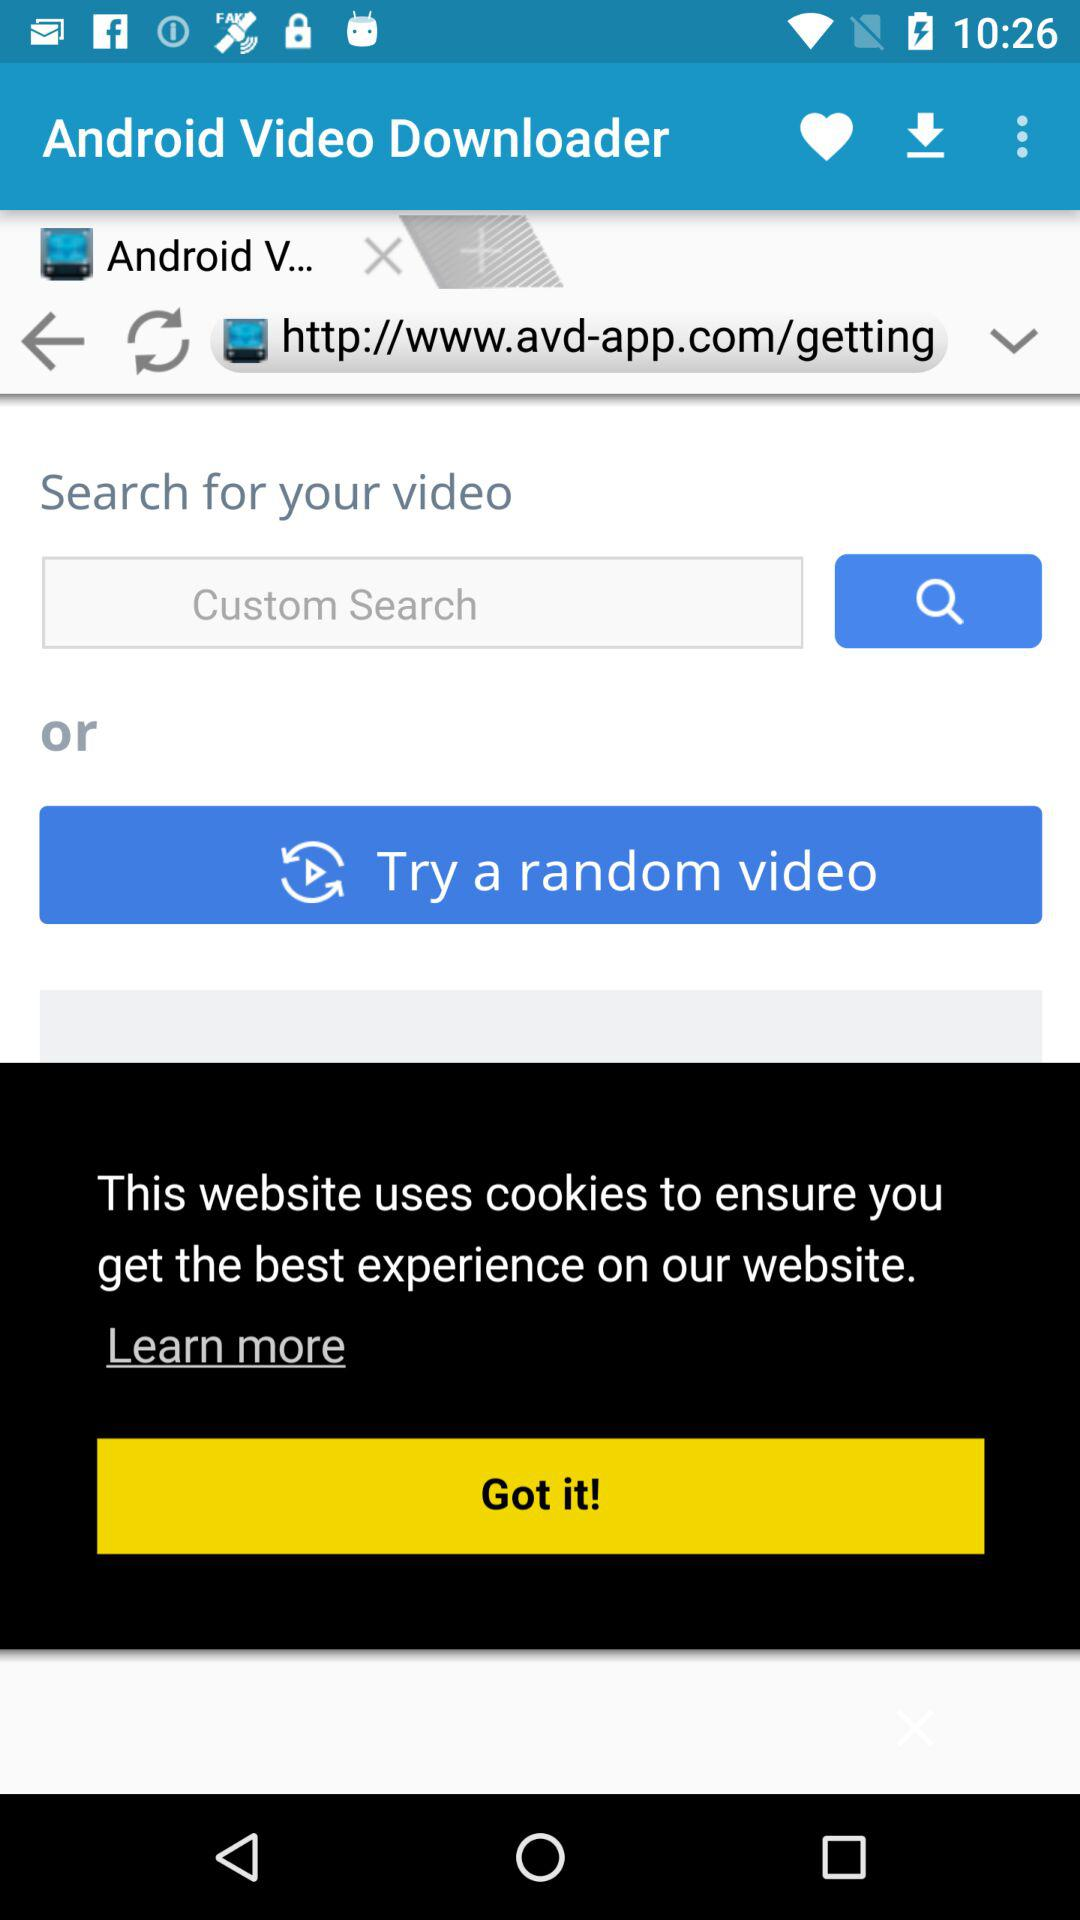What is the name of the application? The name of the application is "Android Video Downloader". 